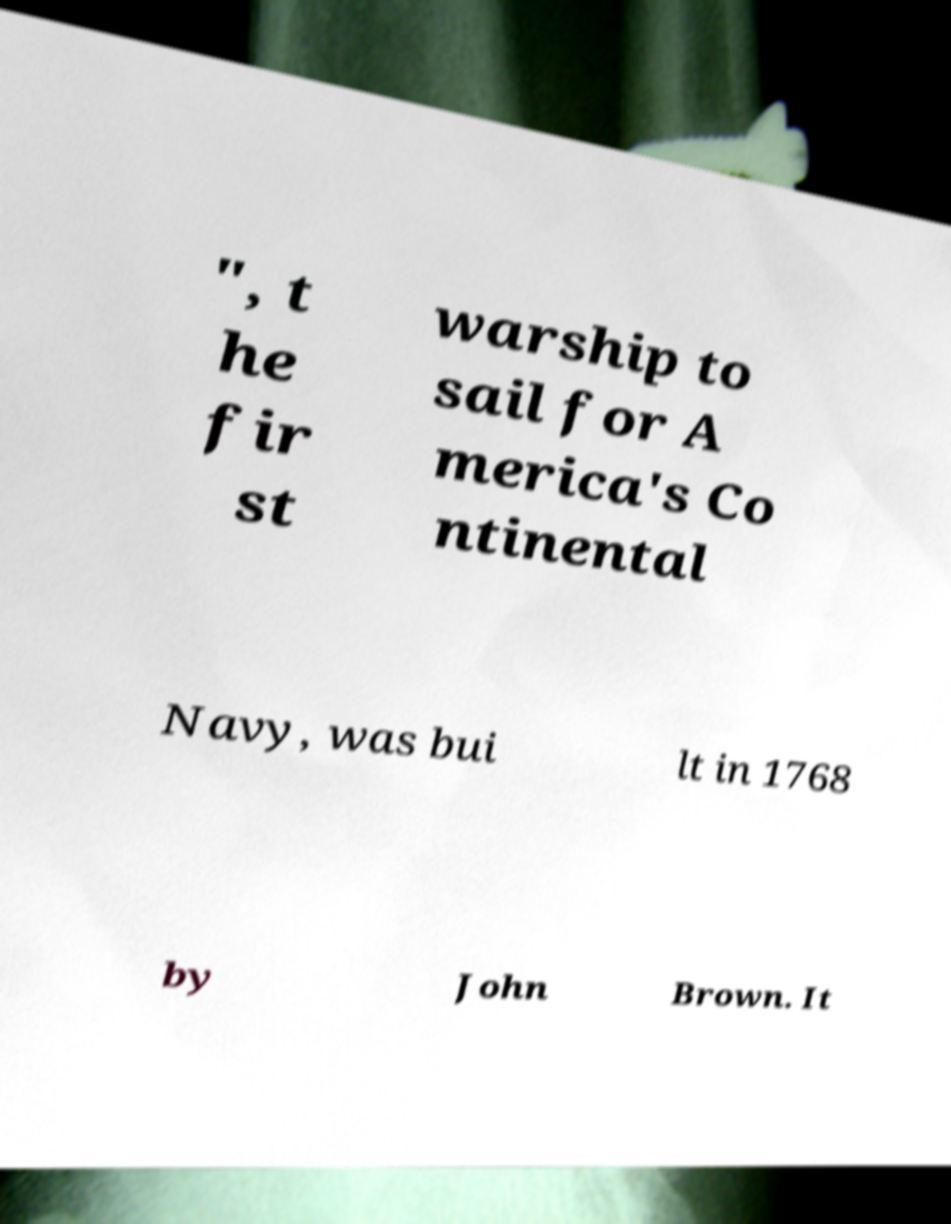There's text embedded in this image that I need extracted. Can you transcribe it verbatim? ", t he fir st warship to sail for A merica's Co ntinental Navy, was bui lt in 1768 by John Brown. It 